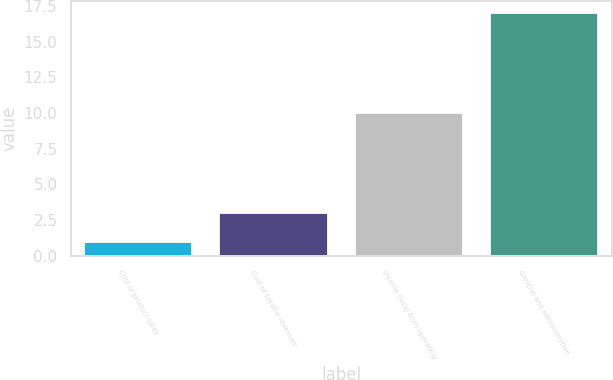Convert chart to OTSL. <chart><loc_0><loc_0><loc_500><loc_500><bar_chart><fcel>Cost of product sales<fcel>Cost of service revenues<fcel>Income (loss) from operating<fcel>General and administrative<nl><fcel>1<fcel>3<fcel>10<fcel>17<nl></chart> 